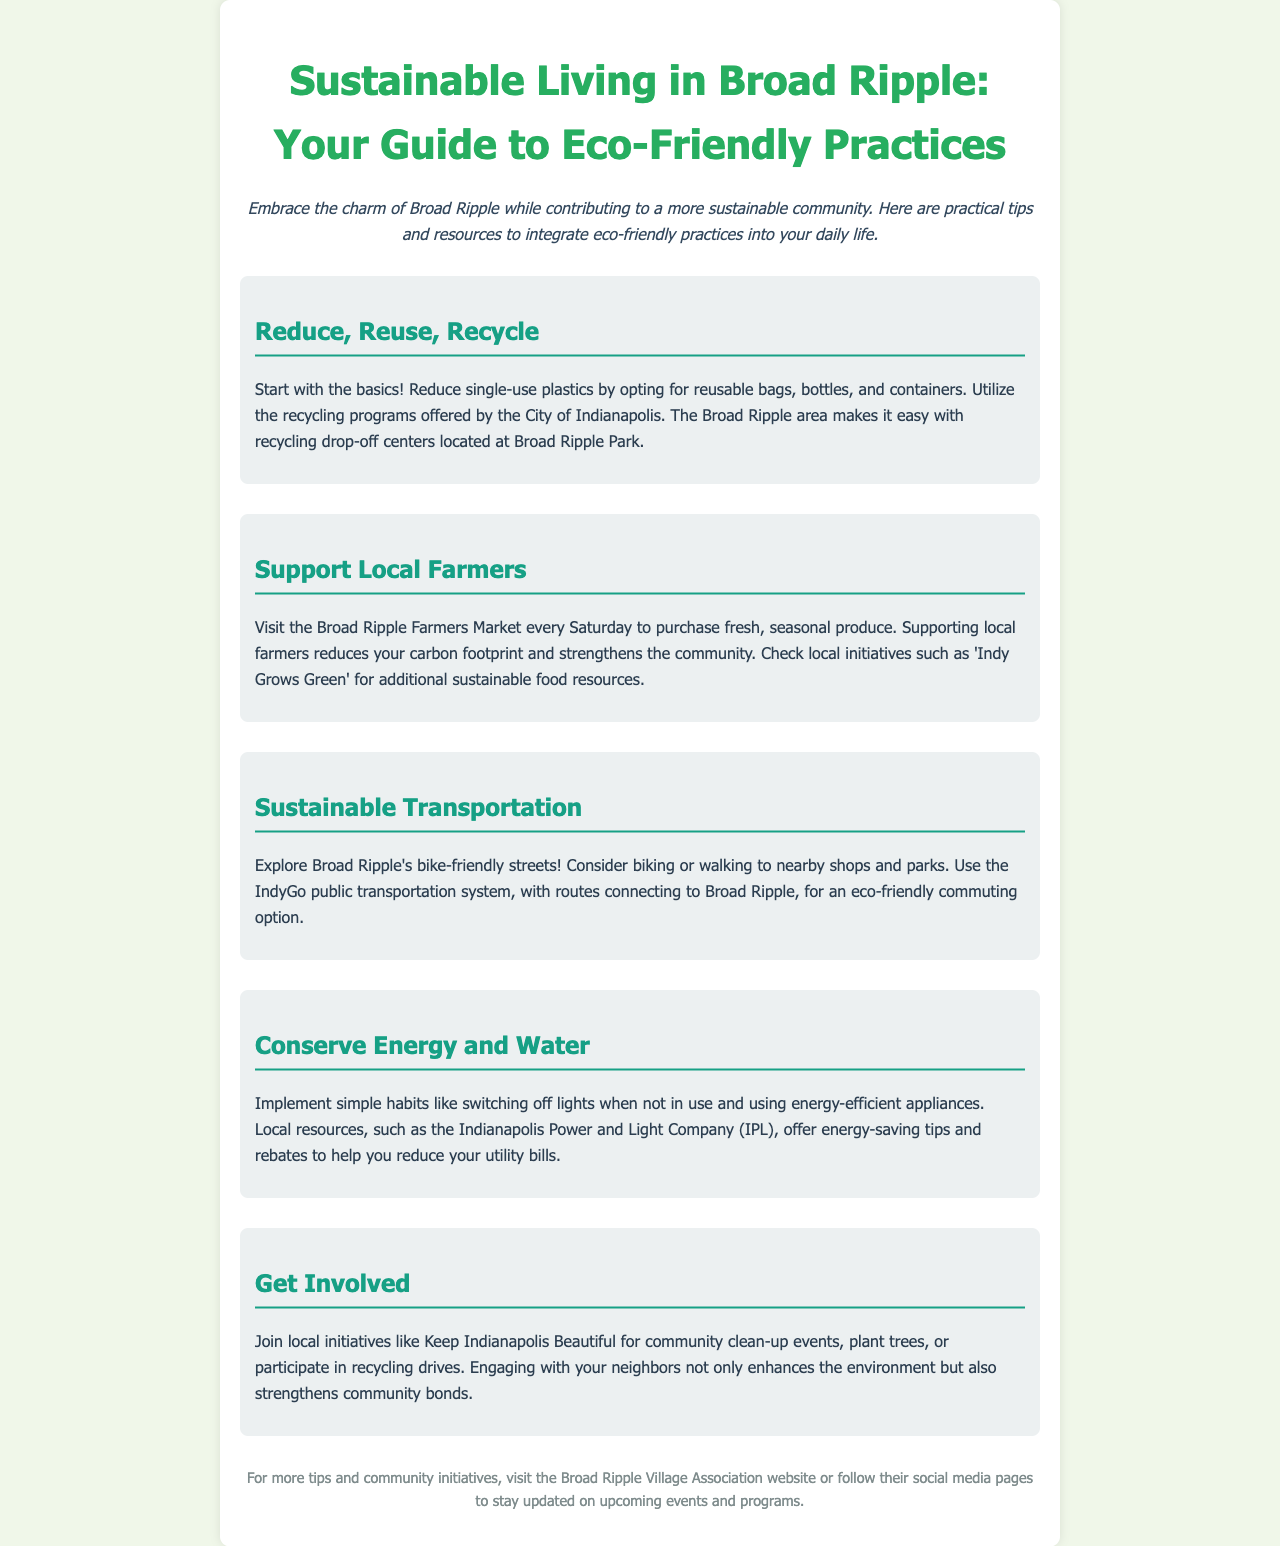What is the title of the brochure? The title is found at the top of the document.
Answer: Sustainable Living in Broad Ripple: Your Guide to Eco-Friendly Practices Where can you find recycling drop-off centers in Broad Ripple? The recycling drop-off centers are mentioned in relation to a specific local area.
Answer: Broad Ripple Park What day is the Broad Ripple Farmers Market held? The document provides the weekly schedule for the market.
Answer: Saturday Which public transportation system connects to Broad Ripple? The document specifies a transportation option for eco-friendly commuting.
Answer: IndyGo What local initiative can you join for community clean-up events? This initiative is mentioned in a section encouraging community involvement.
Answer: Keep Indianapolis Beautiful What is one habit to conserve energy mentioned in the brochure? The document lists specific simple habits for energy conservation.
Answer: Switching off lights Which company offers energy-saving tips and rebates? The source of support for energy conservation is identified in the document.
Answer: Indianapolis Power and Light Company (IPL) What is the main theme of the document? The overall subject covered is implied in the introduction and title.
Answer: Sustainable living 